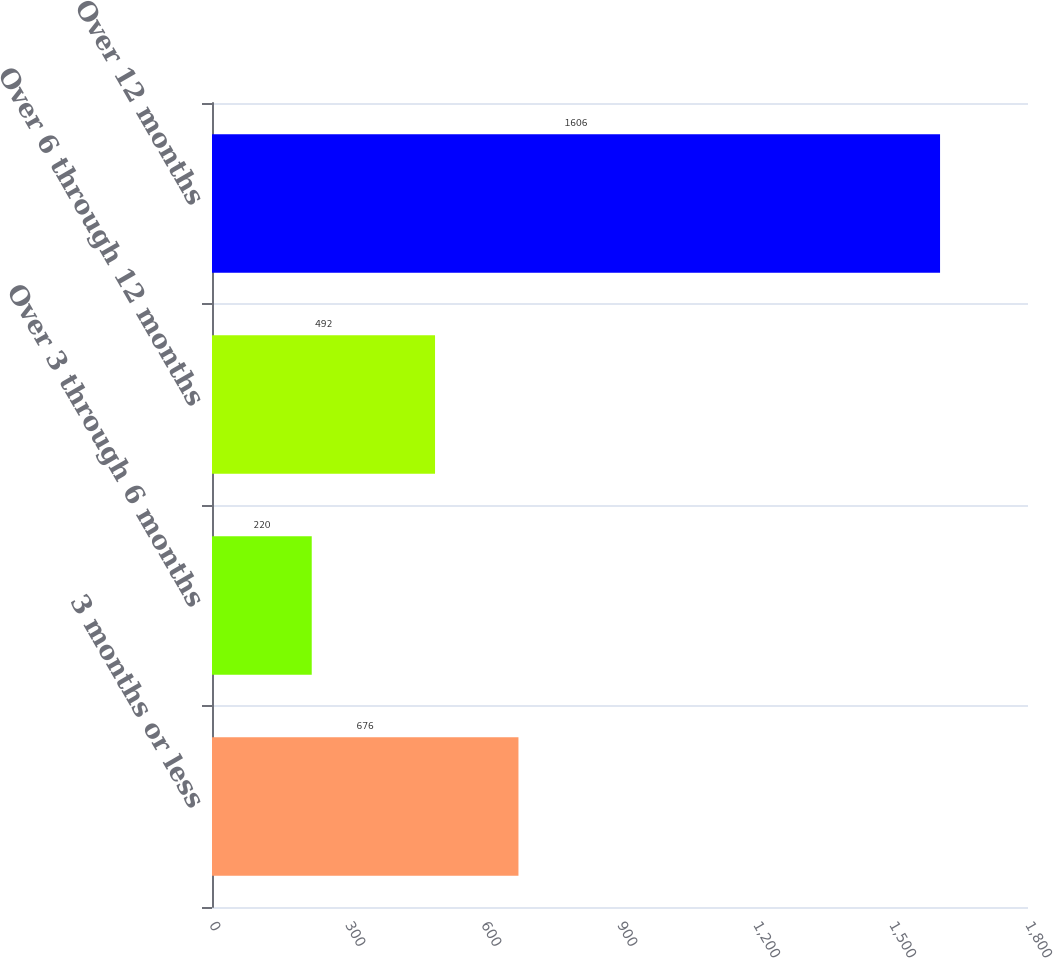Convert chart to OTSL. <chart><loc_0><loc_0><loc_500><loc_500><bar_chart><fcel>3 months or less<fcel>Over 3 through 6 months<fcel>Over 6 through 12 months<fcel>Over 12 months<nl><fcel>676<fcel>220<fcel>492<fcel>1606<nl></chart> 